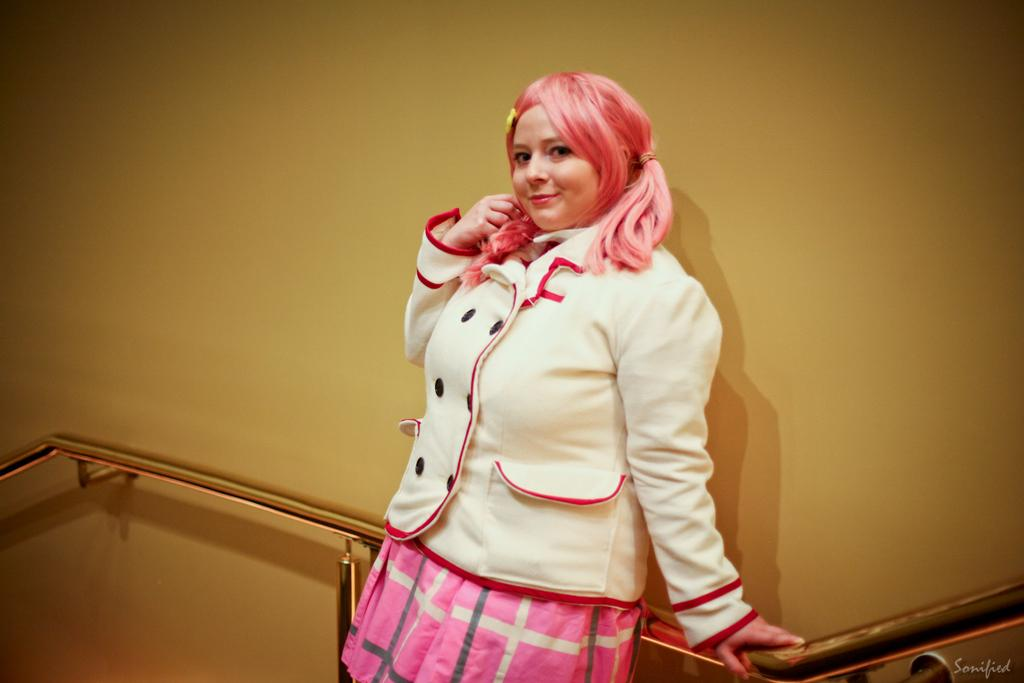Who is present in the image? There is a woman in the image. What is the woman doing in the image? The woman is standing and smiling. What can be seen attached to the wall in the image? There is a handrail attached to the wall in the image. Is there any text or marking in the image? Yes, there is a watermark in the bottom right corner of the image. What type of prison can be seen in the background of the image? There is no prison present in the image; it features a woman standing with a handrail attached to the wall. How does the woman increase her grip on the handrail in the image? The image does not show the woman gripping the handrail or any action related to increasing her grip. 